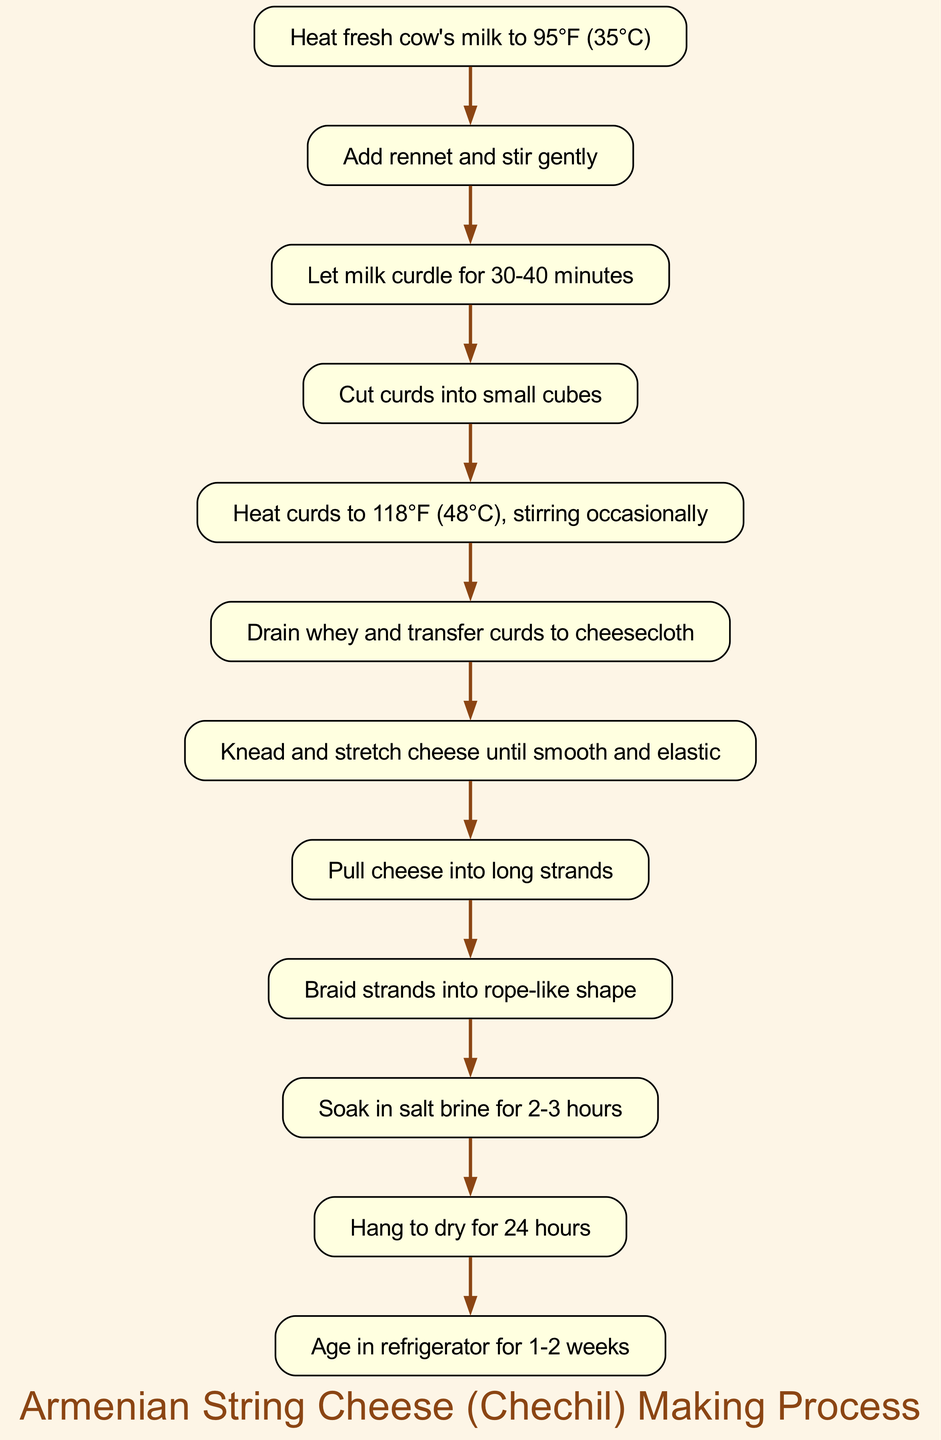What is the first step of the process? The first step in the diagram is to "Heat fresh cow's milk to 95°F (35°C)", which is listed at the top of the flowchart as the initial action needed to start the cheese-making process.
Answer: Heat fresh cow's milk to 95°F (35°C) How many steps are in the process? By counting the nodes in the diagram, we can identify that there are a total of 12 distinct steps involved in making Armenian string cheese.
Answer: 12 What temperature do you heat the curds to? From the diagram, the step indicates heating curds to "118°F (48°C)", which is one of the critical temperature points for the cheese-making process.
Answer: 118°F (48°C) What do you do after pulling the cheese into long strands? Following the action of pulling cheese into long strands, the next step in the flowchart is to "Braid strands into rope-like shape", indicating the progression in the cheese handling process.
Answer: Braid strands into rope-like shape How long do you soak the cheese in salt brine? The diagram specifies that the cheese should "Soak in salt brine for 2-3 hours", which is a crucial step for flavoring the cheese before the drying process.
Answer: 2-3 hours What is the last step of the procedure? The final step outlined in the flowchart is "Age in refrigerator for 1-2 weeks", which signifies the concluding phase of the cheese-making process where it develops flavor over time.
Answer: Age in refrigerator for 1-2 weeks What is done with the curds after draining the whey? Once the whey is drained, the immediate subsequent step shown in the diagram is to "Transfer curds to cheesecloth", highlighting the transition in the cheese-making process.
Answer: Transfer curds to cheesecloth What do you do after kneading and stretching the cheese? After kneading and stretching the cheese, the next action according to the diagram is to "Pull cheese into long strands", indicating the transformation of the cheese into its final form.
Answer: Pull cheese into long strands 